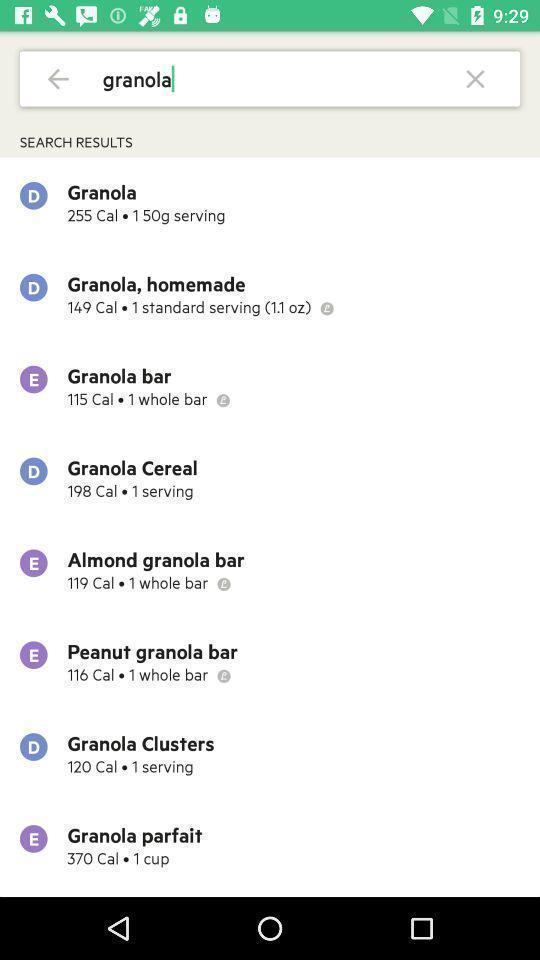Tell me about the visual elements in this screen capture. Screen displaying the search result. 